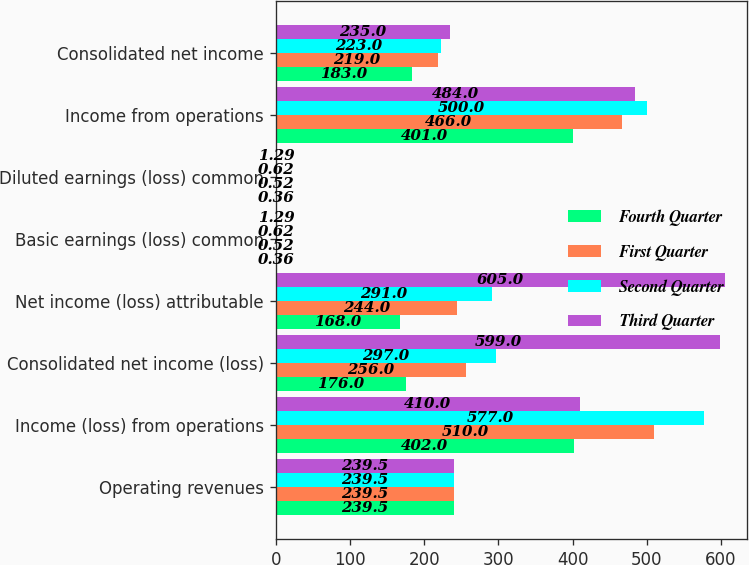Convert chart to OTSL. <chart><loc_0><loc_0><loc_500><loc_500><stacked_bar_chart><ecel><fcel>Operating revenues<fcel>Income (loss) from operations<fcel>Consolidated net income (loss)<fcel>Net income (loss) attributable<fcel>Basic earnings (loss) common<fcel>Diluted earnings (loss) common<fcel>Income from operations<fcel>Consolidated net income<nl><fcel>Fourth Quarter<fcel>239.5<fcel>402<fcel>176<fcel>168<fcel>0.36<fcel>0.36<fcel>401<fcel>183<nl><fcel>First Quarter<fcel>239.5<fcel>510<fcel>256<fcel>244<fcel>0.52<fcel>0.52<fcel>466<fcel>219<nl><fcel>Second Quarter<fcel>239.5<fcel>577<fcel>297<fcel>291<fcel>0.62<fcel>0.62<fcel>500<fcel>223<nl><fcel>Third Quarter<fcel>239.5<fcel>410<fcel>599<fcel>605<fcel>1.29<fcel>1.29<fcel>484<fcel>235<nl></chart> 